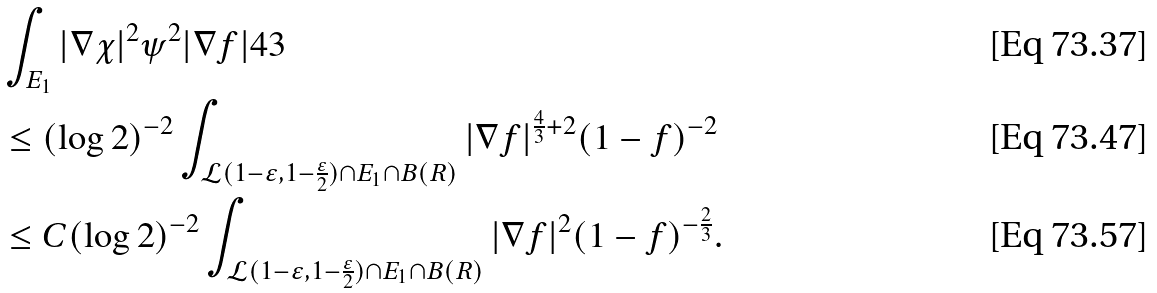<formula> <loc_0><loc_0><loc_500><loc_500>& \int _ { E _ { 1 } } | \nabla \chi | ^ { 2 } \psi ^ { 2 } | \nabla f | ^ { } { 4 } 3 \\ & \leq ( \log 2 ) ^ { - 2 } \int _ { \mathcal { L } ( 1 - \varepsilon , 1 - \frac { \varepsilon } 2 ) \cap E _ { 1 } \cap B ( R ) } | \nabla f | ^ { \frac { 4 } { 3 } + 2 } ( 1 - f ) ^ { - 2 } \\ & \leq C ( \log 2 ) ^ { - 2 } \int _ { \mathcal { L } ( 1 - \varepsilon , 1 - \frac { \varepsilon } 2 ) \cap E _ { 1 } \cap B ( R ) } | \nabla f | ^ { 2 } ( 1 - f ) ^ { - \frac { 2 } { 3 } } .</formula> 